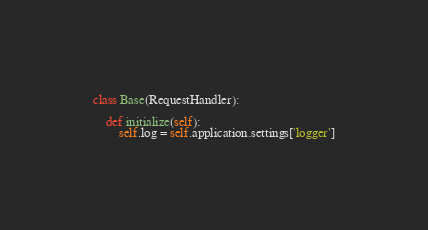Convert code to text. <code><loc_0><loc_0><loc_500><loc_500><_Python_>
class Base(RequestHandler):

    def initialize(self):
        self.log = self.application.settings['logger']
</code> 